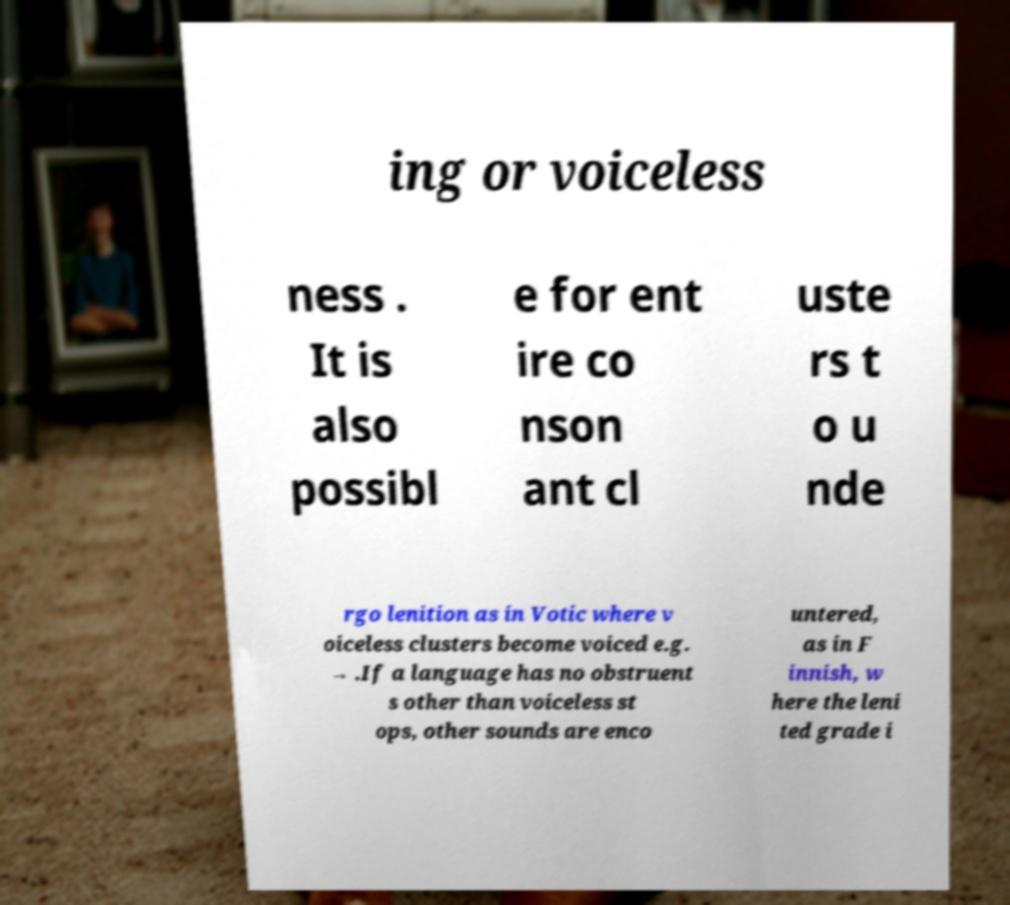I need the written content from this picture converted into text. Can you do that? ing or voiceless ness . It is also possibl e for ent ire co nson ant cl uste rs t o u nde rgo lenition as in Votic where v oiceless clusters become voiced e.g. → .If a language has no obstruent s other than voiceless st ops, other sounds are enco untered, as in F innish, w here the leni ted grade i 